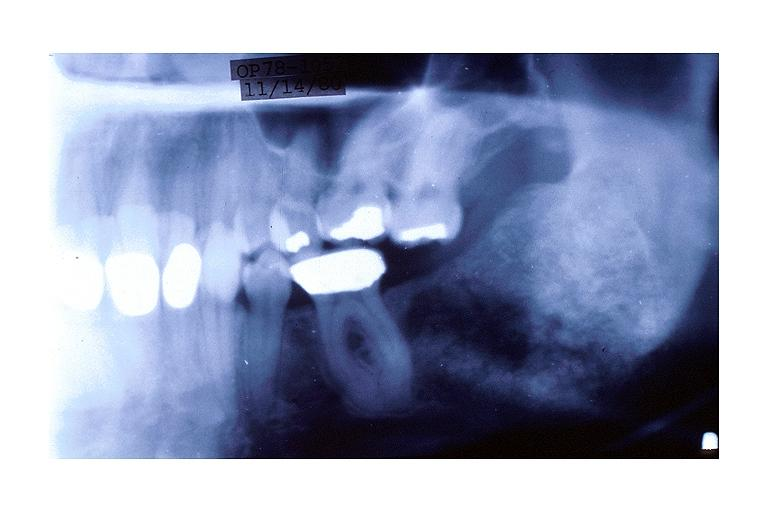where is this?
Answer the question using a single word or phrase. Oral 